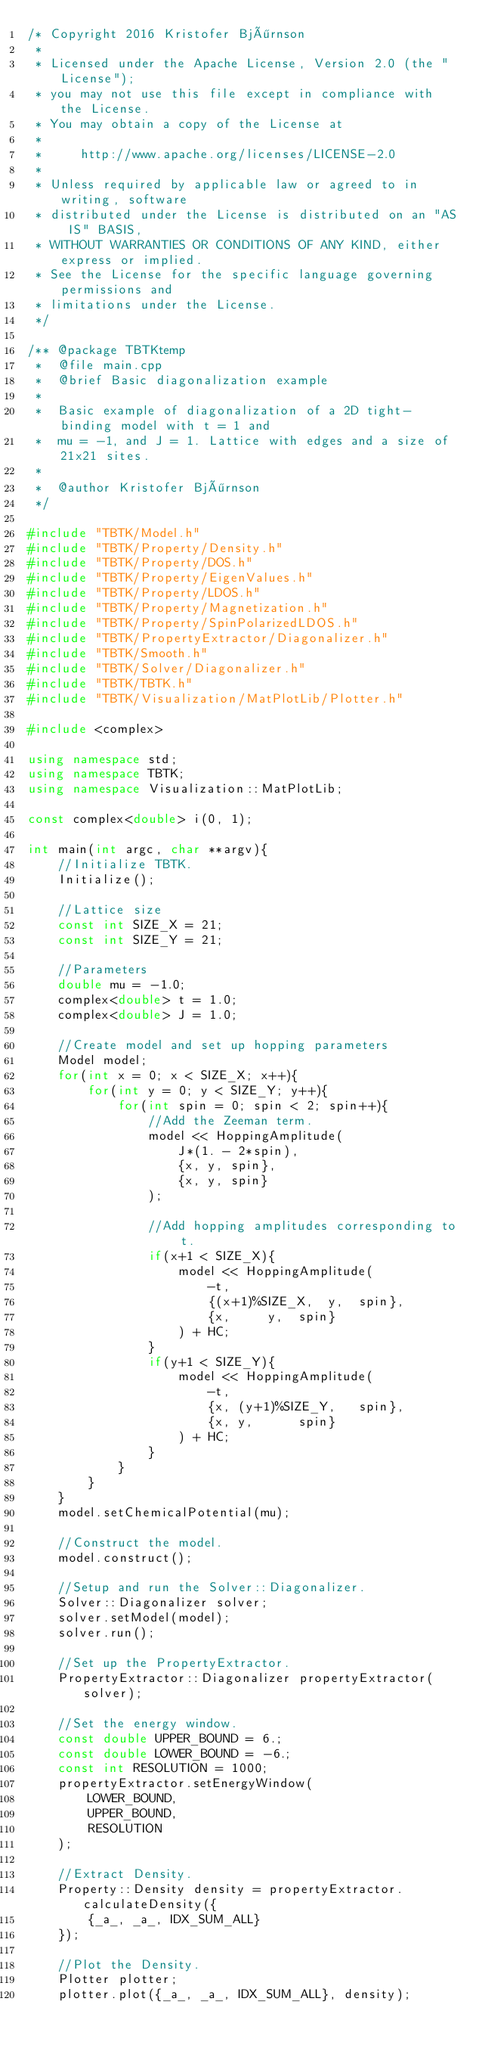<code> <loc_0><loc_0><loc_500><loc_500><_C++_>/* Copyright 2016 Kristofer Björnson
 *
 * Licensed under the Apache License, Version 2.0 (the "License");
 * you may not use this file except in compliance with the License.
 * You may obtain a copy of the License at
 *
 *     http://www.apache.org/licenses/LICENSE-2.0
 *
 * Unless required by applicable law or agreed to in writing, software
 * distributed under the License is distributed on an "AS IS" BASIS,
 * WITHOUT WARRANTIES OR CONDITIONS OF ANY KIND, either express or implied.
 * See the License for the specific language governing permissions and
 * limitations under the License.
 */

/** @package TBTKtemp
 *  @file main.cpp
 *  @brief Basic diagonalization example
 *
 *  Basic example of diagonalization of a 2D tight-binding model with t = 1 and
 *  mu = -1, and J = 1. Lattice with edges and a size of 21x21 sites.
 *
 *  @author Kristofer Björnson
 */

#include "TBTK/Model.h"
#include "TBTK/Property/Density.h"
#include "TBTK/Property/DOS.h"
#include "TBTK/Property/EigenValues.h"
#include "TBTK/Property/LDOS.h"
#include "TBTK/Property/Magnetization.h"
#include "TBTK/Property/SpinPolarizedLDOS.h"
#include "TBTK/PropertyExtractor/Diagonalizer.h"
#include "TBTK/Smooth.h"
#include "TBTK/Solver/Diagonalizer.h"
#include "TBTK/TBTK.h"
#include "TBTK/Visualization/MatPlotLib/Plotter.h"

#include <complex>

using namespace std;
using namespace TBTK;
using namespace Visualization::MatPlotLib;

const complex<double> i(0, 1);

int main(int argc, char **argv){
	//Initialize TBTK.
	Initialize();

	//Lattice size
	const int SIZE_X = 21;
	const int SIZE_Y = 21;

	//Parameters
	double mu = -1.0;
	complex<double> t = 1.0;
	complex<double> J = 1.0;

	//Create model and set up hopping parameters
	Model model;
	for(int x = 0; x < SIZE_X; x++){
		for(int y = 0; y < SIZE_Y; y++){
			for(int spin = 0; spin < 2; spin++){
				//Add the Zeeman term.
				model << HoppingAmplitude(
					J*(1. - 2*spin),
					{x, y, spin},
					{x, y, spin}
				);

				//Add hopping amplitudes corresponding to t.
				if(x+1 < SIZE_X){
					model << HoppingAmplitude(
						-t,
						{(x+1)%SIZE_X,	y,	spin},
						{x,		y,	spin}
					) + HC;
				}
				if(y+1 < SIZE_Y){
					model << HoppingAmplitude(
						-t,
						{x,	(y+1)%SIZE_Y,	spin},
						{x,	y,		spin}
					) + HC;
				}
			}
		}
	}
	model.setChemicalPotential(mu);

	//Construct the model.
	model.construct();

	//Setup and run the Solver::Diagonalizer.
	Solver::Diagonalizer solver;
	solver.setModel(model);
	solver.run();

	//Set up the PropertyExtractor.
	PropertyExtractor::Diagonalizer propertyExtractor(solver);

	//Set the energy window.
	const double UPPER_BOUND = 6.;
	const double LOWER_BOUND = -6.;
	const int RESOLUTION = 1000;
	propertyExtractor.setEnergyWindow(
		LOWER_BOUND,
		UPPER_BOUND,
		RESOLUTION
	);

	//Extract Density.
	Property::Density density = propertyExtractor.calculateDensity({
		{_a_, _a_, IDX_SUM_ALL}
	});

	//Plot the Density.
	Plotter plotter;
	plotter.plot({_a_, _a_, IDX_SUM_ALL}, density);</code> 